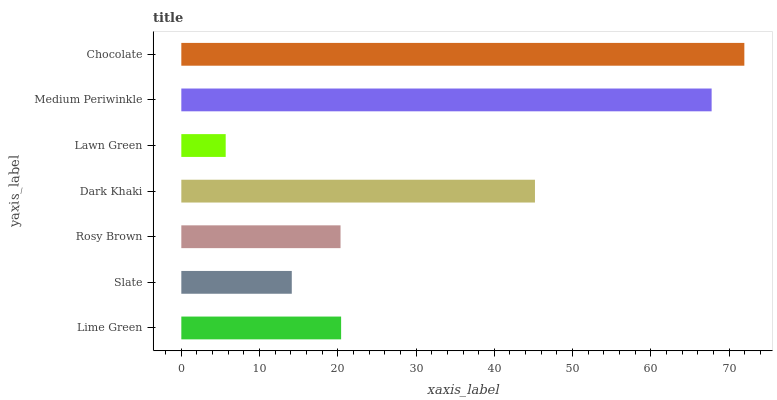Is Lawn Green the minimum?
Answer yes or no. Yes. Is Chocolate the maximum?
Answer yes or no. Yes. Is Slate the minimum?
Answer yes or no. No. Is Slate the maximum?
Answer yes or no. No. Is Lime Green greater than Slate?
Answer yes or no. Yes. Is Slate less than Lime Green?
Answer yes or no. Yes. Is Slate greater than Lime Green?
Answer yes or no. No. Is Lime Green less than Slate?
Answer yes or no. No. Is Lime Green the high median?
Answer yes or no. Yes. Is Lime Green the low median?
Answer yes or no. Yes. Is Lawn Green the high median?
Answer yes or no. No. Is Slate the low median?
Answer yes or no. No. 